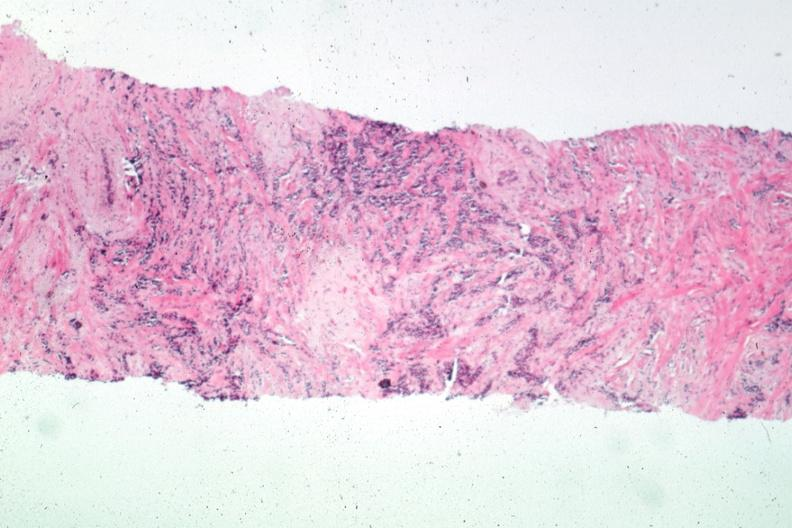does this image show needle biopsy with obvious carcinoma?
Answer the question using a single word or phrase. Yes 